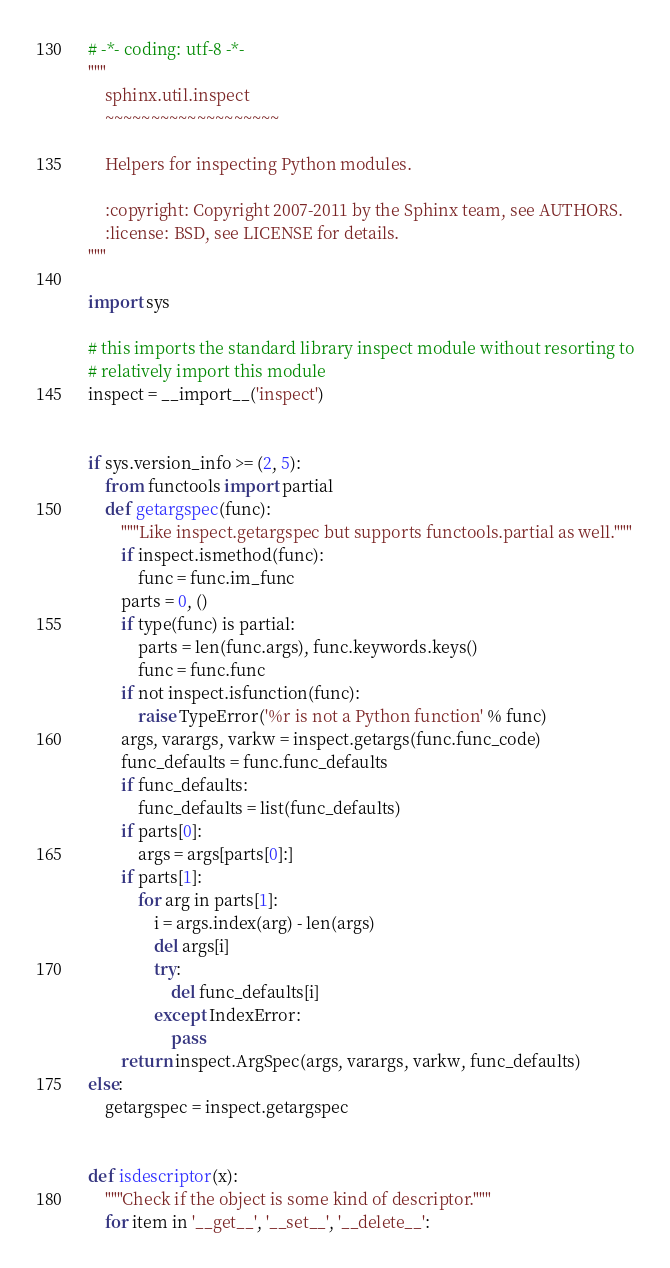Convert code to text. <code><loc_0><loc_0><loc_500><loc_500><_Python_># -*- coding: utf-8 -*-
"""
    sphinx.util.inspect
    ~~~~~~~~~~~~~~~~~~~

    Helpers for inspecting Python modules.

    :copyright: Copyright 2007-2011 by the Sphinx team, see AUTHORS.
    :license: BSD, see LICENSE for details.
"""

import sys

# this imports the standard library inspect module without resorting to
# relatively import this module
inspect = __import__('inspect')


if sys.version_info >= (2, 5):
    from functools import partial
    def getargspec(func):
        """Like inspect.getargspec but supports functools.partial as well."""
        if inspect.ismethod(func):
            func = func.im_func
        parts = 0, ()
        if type(func) is partial:
            parts = len(func.args), func.keywords.keys()
            func = func.func
        if not inspect.isfunction(func):
            raise TypeError('%r is not a Python function' % func)
        args, varargs, varkw = inspect.getargs(func.func_code)
        func_defaults = func.func_defaults
        if func_defaults:
            func_defaults = list(func_defaults)
        if parts[0]:
            args = args[parts[0]:]
        if parts[1]:
            for arg in parts[1]:
                i = args.index(arg) - len(args)
                del args[i]
                try:
                    del func_defaults[i]
                except IndexError:
                    pass
        return inspect.ArgSpec(args, varargs, varkw, func_defaults)
else:
    getargspec = inspect.getargspec


def isdescriptor(x):
    """Check if the object is some kind of descriptor."""
    for item in '__get__', '__set__', '__delete__':</code> 